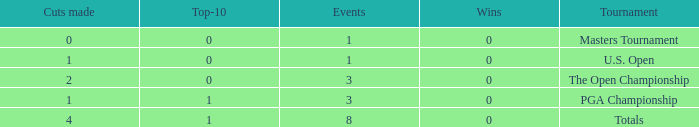For more than 3 events in the PGA Championship, what is the fewest number of wins? None. 